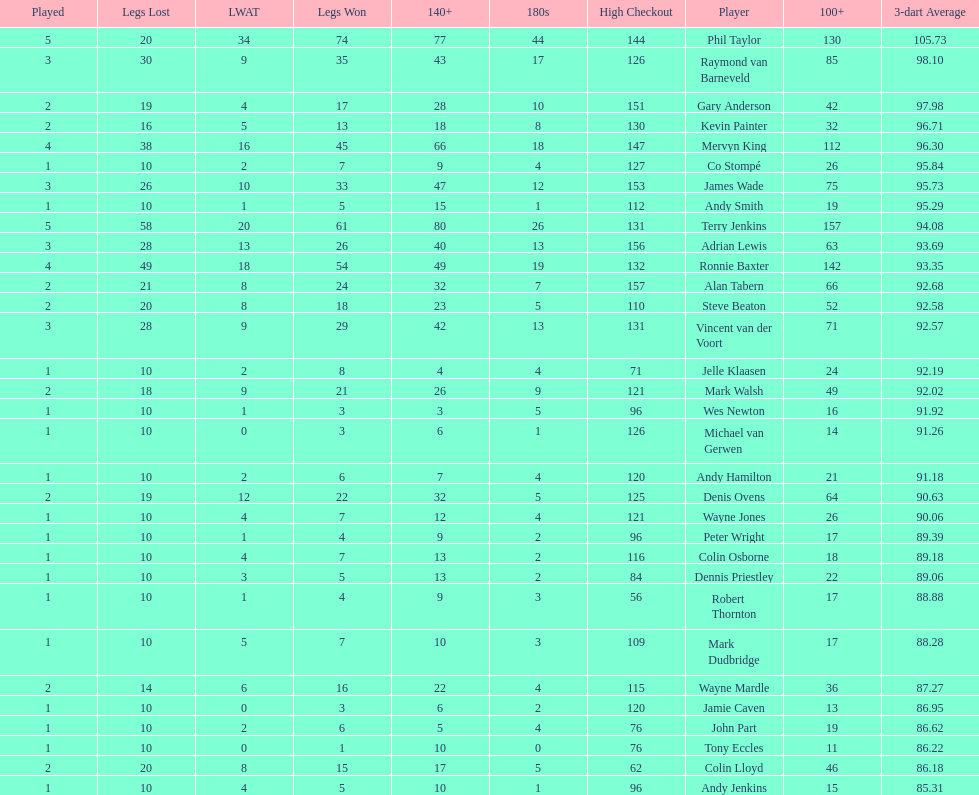What is the total amount of players who played more than 3 games? 4. 